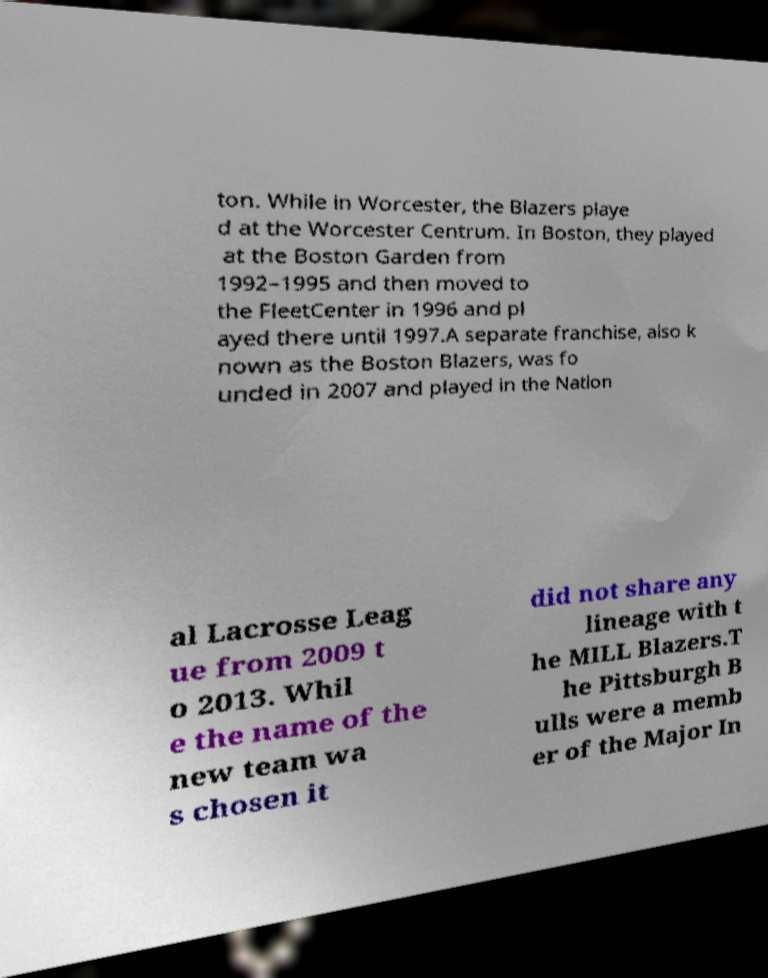Can you read and provide the text displayed in the image?This photo seems to have some interesting text. Can you extract and type it out for me? ton. While in Worcester, the Blazers playe d at the Worcester Centrum. In Boston, they played at the Boston Garden from 1992–1995 and then moved to the FleetCenter in 1996 and pl ayed there until 1997.A separate franchise, also k nown as the Boston Blazers, was fo unded in 2007 and played in the Nation al Lacrosse Leag ue from 2009 t o 2013. Whil e the name of the new team wa s chosen it did not share any lineage with t he MILL Blazers.T he Pittsburgh B ulls were a memb er of the Major In 